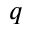Convert formula to latex. <formula><loc_0><loc_0><loc_500><loc_500>q</formula> 